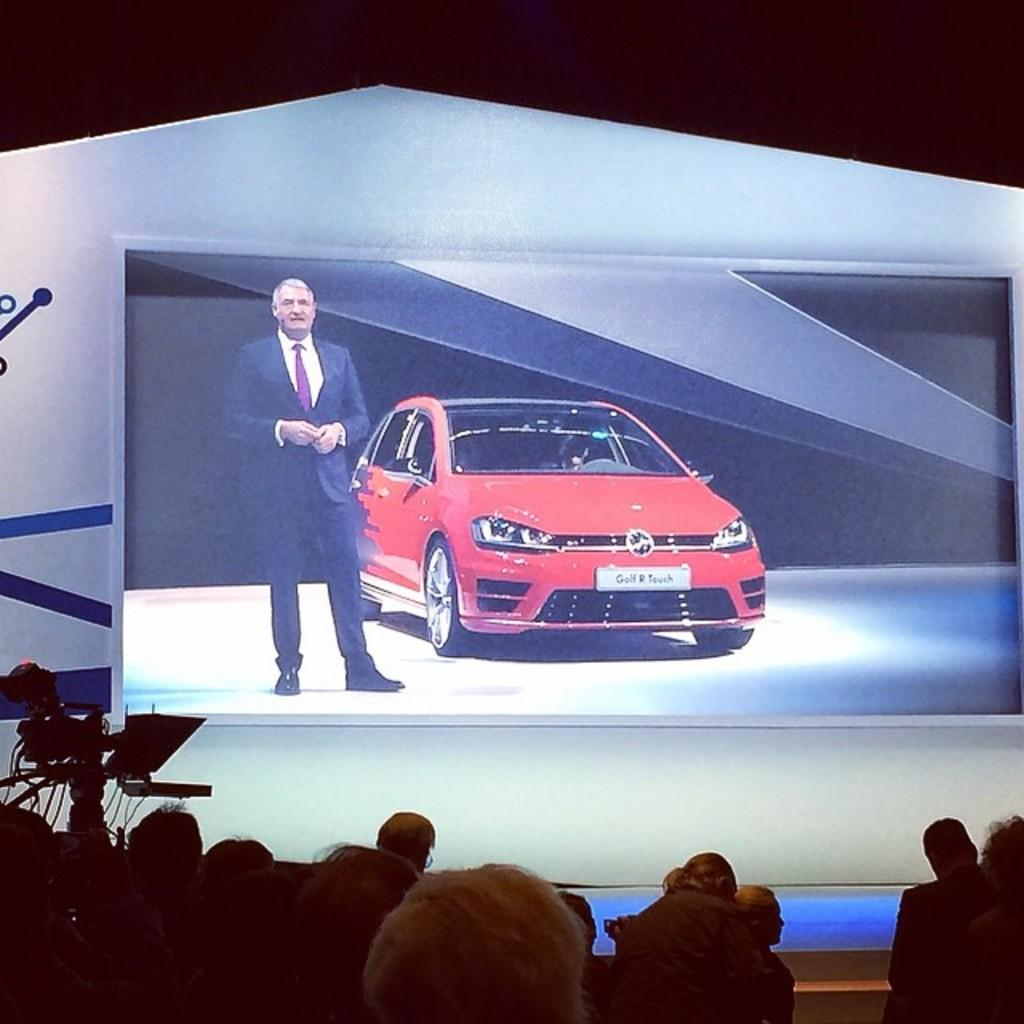What is the main subject of the large picture in the image? There is a large picture of a car in the image. Who is standing beside the car in the image? A man is standing beside the car in the image. What can be seen in front of the car in the image? There are cameras in front of the car in the image. What is happening in the hall in the image? There are people gathered in a hall in the image. What type of soda is being served in the hall in the image? There is no mention of soda or any beverages in the image. What is the zephyr doing in the image? There is no mention of a zephyr or any weather phenomenon in the image. 